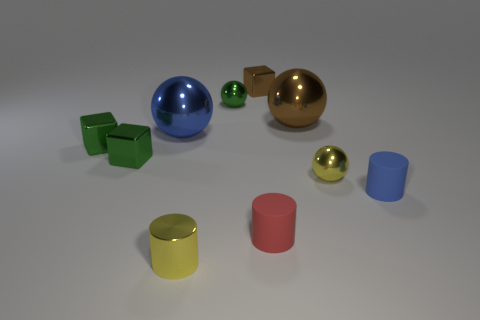What number of blue cylinders have the same material as the tiny red thing? 1 